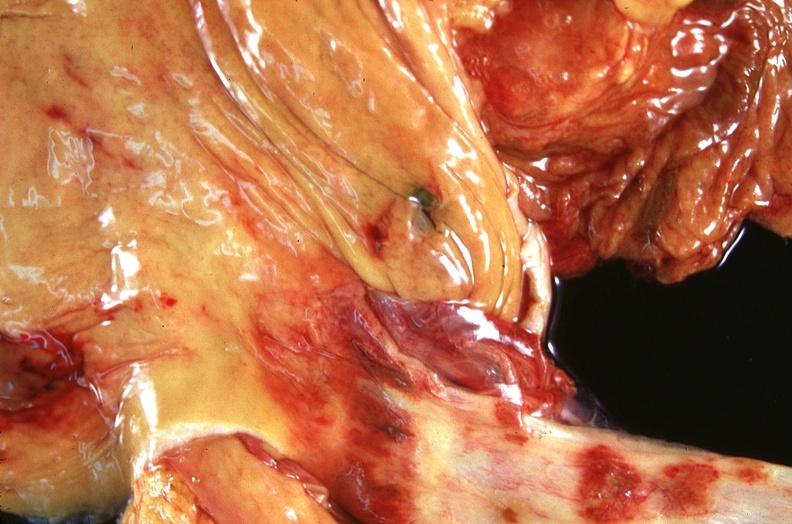s this typical thecoma with yellow foci present?
Answer the question using a single word or phrase. No 